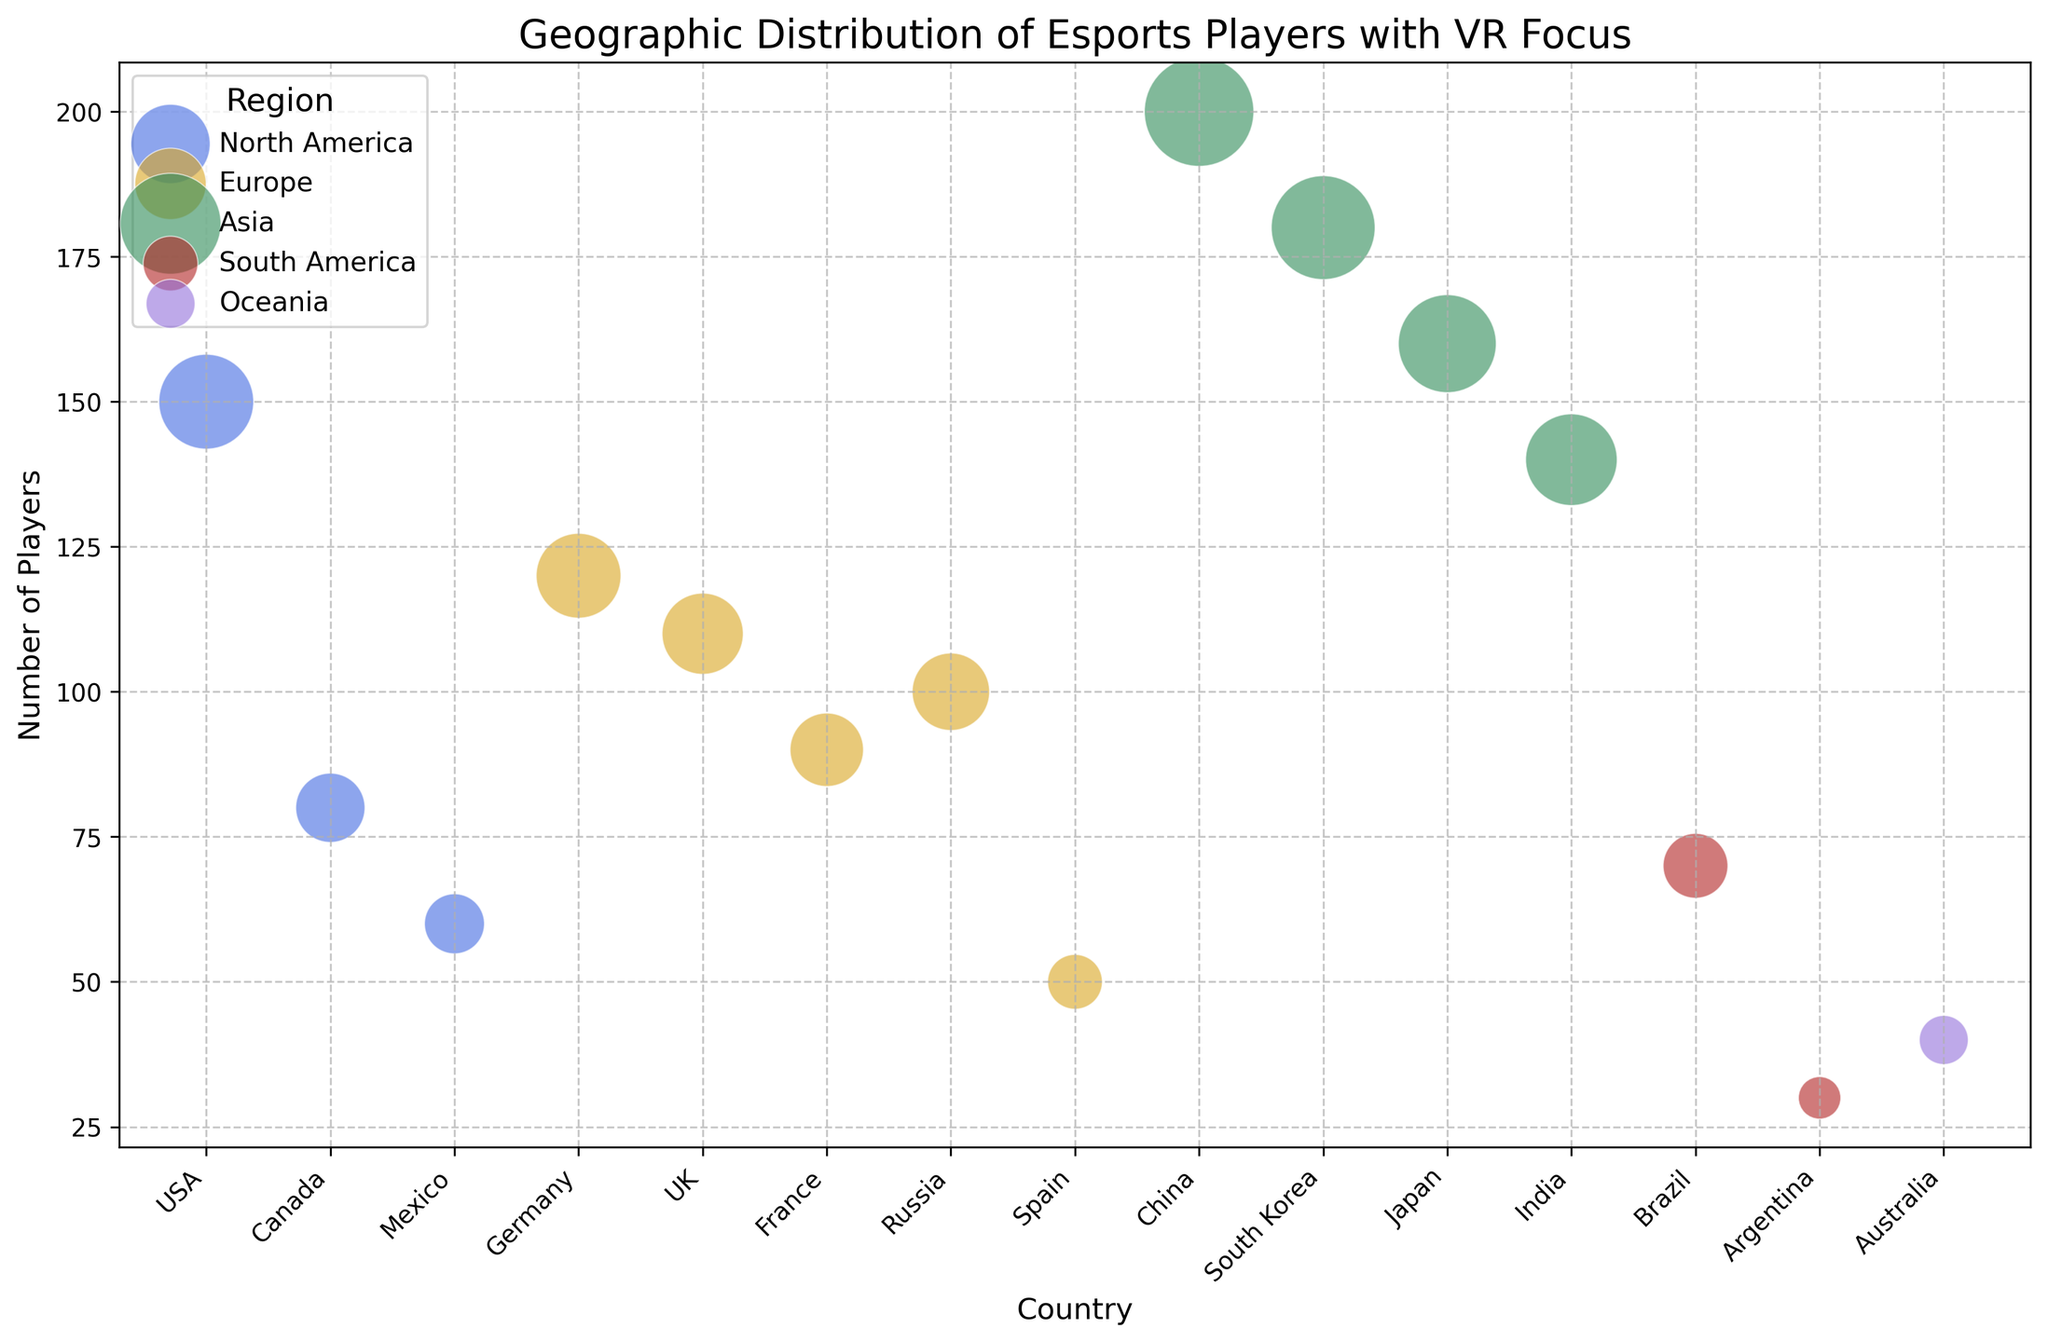Which country has the highest number of VR esports players? To find the country with the highest number of VR esports players, look at the y-axis to see the counts. The tallest bubble will indicate this. China has the bubble positioned highest on the y-axis, suggesting it has the most players.
Answer: China Which region is represented by the color royal blue? By checking the legend for color indications, 'North America' is shown in royal blue color. All bubbles in blue represent North American countries.
Answer: North America How many training facilities are there in North America in total? The countries in North America from the data are the USA, Canada, and Mexico. Summing their facilities: 15 (USA) + 8 (Canada) + 4 (Mexico) = 27.
Answer: 27 Which two countries have exactly the same number of training facilities? Analyzing the bubbles and the y-axis labels, France and Canada both represent the same quantity of training facilities with 8 each.
Answer: France and Canada Which region has the widest range of number of players? Comparing all regions: Asia ranges from India (140) to China (200) = range of 60. Europe ranges from Spain (50) to Germany (120) = range of 70. North America ranges from Mexico (60) to the USA (150) = range of 90. South America ranges from Argentina (30) to Brazil (70) = range of 40. Oceania has only Australia (40), so range = 0. Thus, North America has the widest range.
Answer: North America Which country with more than 100 players has the fewest training facilities? Observing the chart data for countries with more than 100 players (USA, Canada, Germany, UK, China, South Korea, Japan, India), among them, India has the fewest training facilities, only 12.
Answer: India What is the average number of players in European countries? Summing the European countries' players: Germany (120) + UK (110) + France (90) + Russia (100) + Spain (50) = 470. Divide by the number of countries: 470/5 = 94.
Answer: 94 